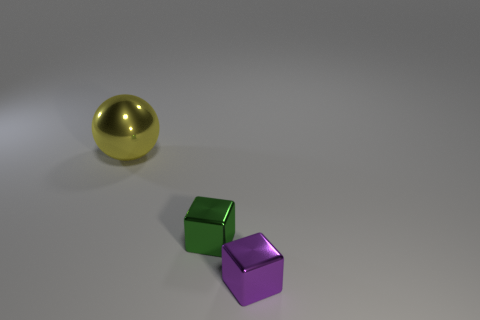Subtract all purple cubes. Subtract all purple cylinders. How many cubes are left? 1 Subtract all yellow blocks. How many blue balls are left? 0 Add 1 tiny things. How many yellows exist? 0 Subtract all yellow things. Subtract all green metallic spheres. How many objects are left? 2 Add 3 large yellow balls. How many large yellow balls are left? 4 Add 1 shiny spheres. How many shiny spheres exist? 2 Add 2 tiny objects. How many objects exist? 5 Subtract all purple cubes. How many cubes are left? 1 Subtract 0 brown balls. How many objects are left? 3 Subtract all blocks. How many objects are left? 1 